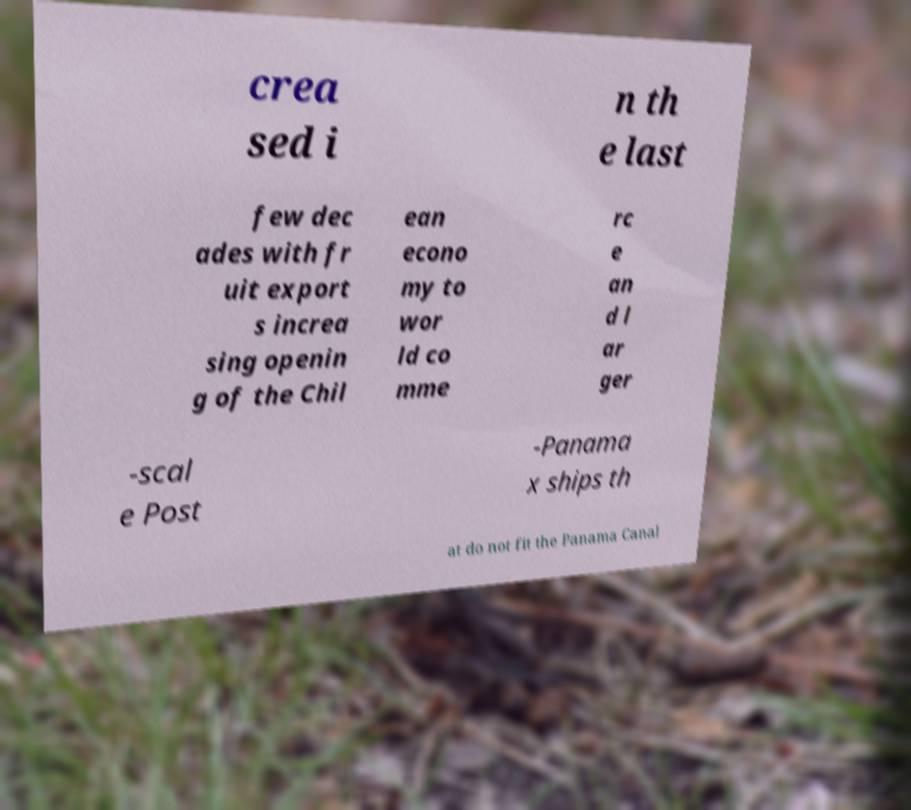There's text embedded in this image that I need extracted. Can you transcribe it verbatim? crea sed i n th e last few dec ades with fr uit export s increa sing openin g of the Chil ean econo my to wor ld co mme rc e an d l ar ger -scal e Post -Panama x ships th at do not fit the Panama Canal 